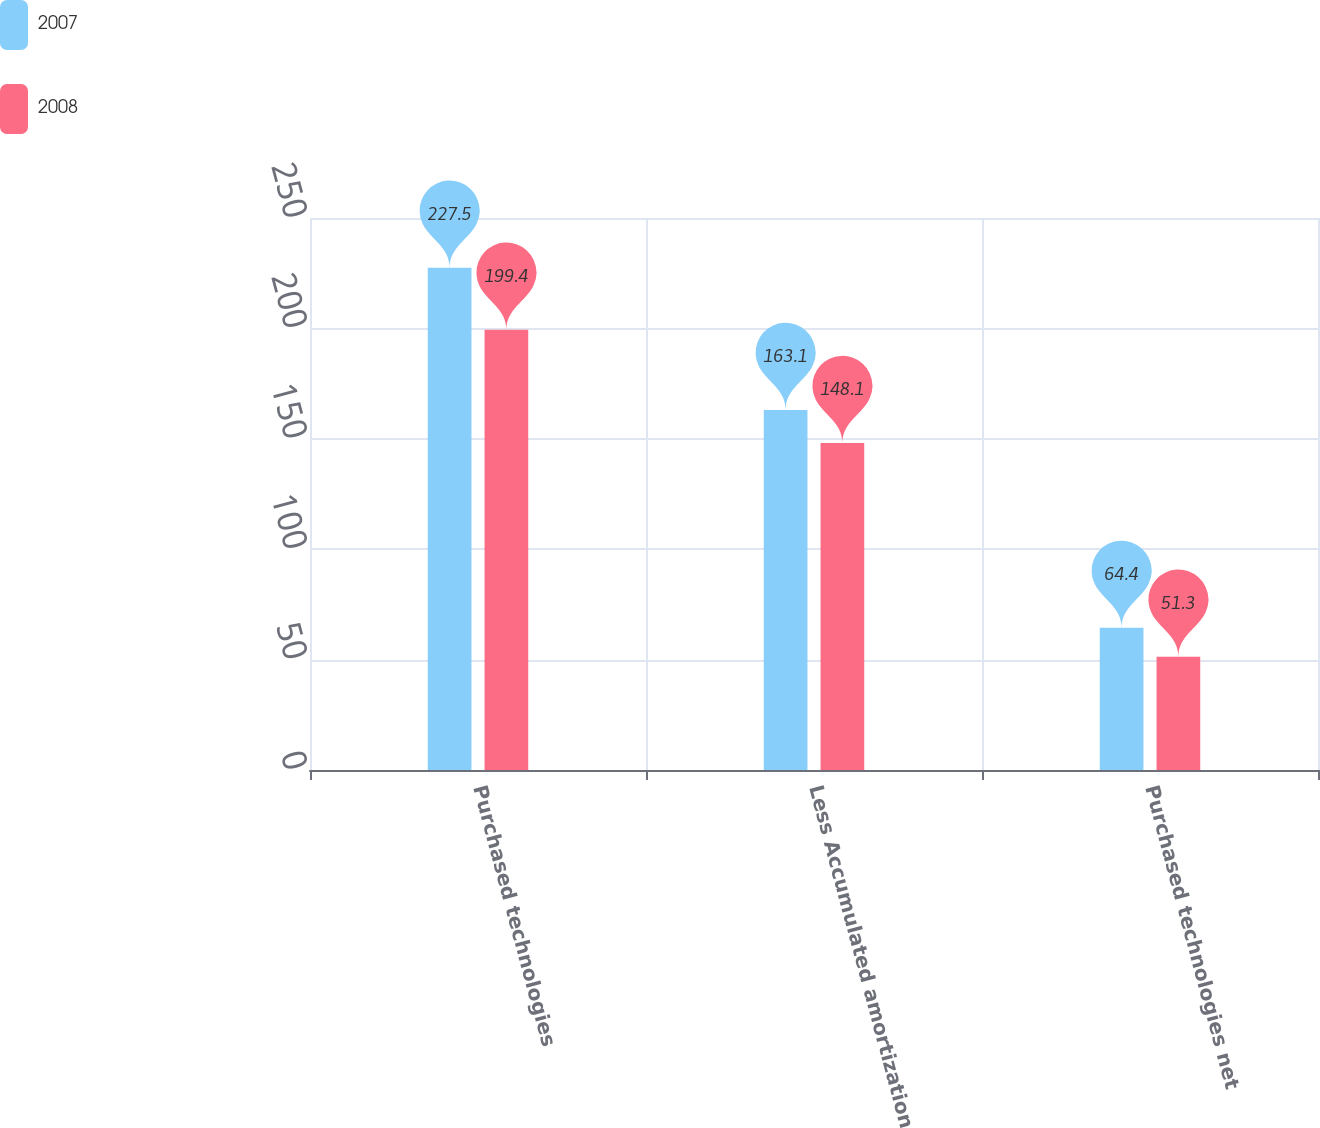Convert chart to OTSL. <chart><loc_0><loc_0><loc_500><loc_500><stacked_bar_chart><ecel><fcel>Purchased technologies<fcel>Less Accumulated amortization<fcel>Purchased technologies net<nl><fcel>2007<fcel>227.5<fcel>163.1<fcel>64.4<nl><fcel>2008<fcel>199.4<fcel>148.1<fcel>51.3<nl></chart> 